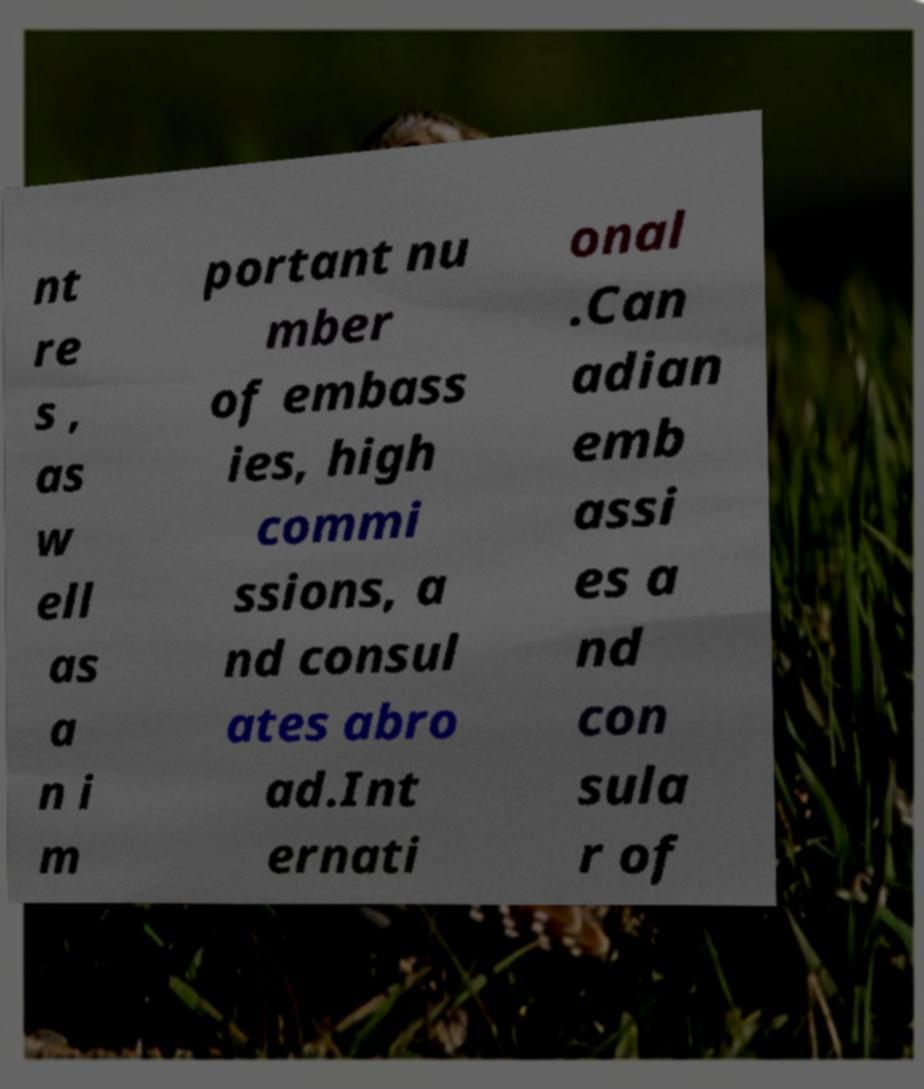Can you read and provide the text displayed in the image?This photo seems to have some interesting text. Can you extract and type it out for me? nt re s , as w ell as a n i m portant nu mber of embass ies, high commi ssions, a nd consul ates abro ad.Int ernati onal .Can adian emb assi es a nd con sula r of 